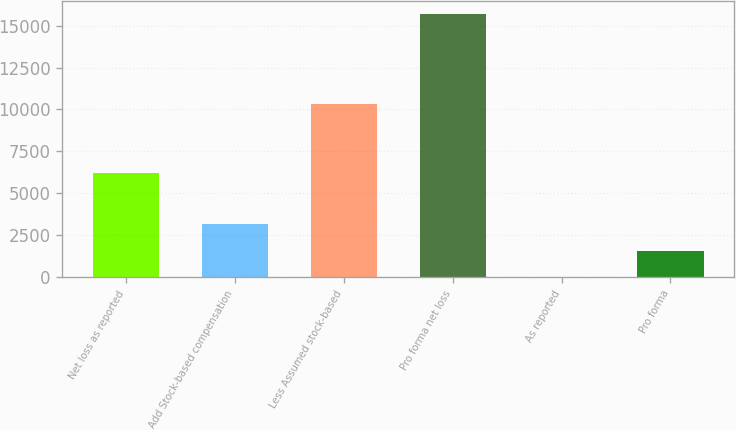Convert chart. <chart><loc_0><loc_0><loc_500><loc_500><bar_chart><fcel>Net loss as reported<fcel>Add Stock-based compensation<fcel>Less Assumed stock-based<fcel>Pro forma net loss<fcel>As reported<fcel>Pro forma<nl><fcel>6225<fcel>3136.73<fcel>10302<fcel>15683<fcel>0.17<fcel>1568.45<nl></chart> 